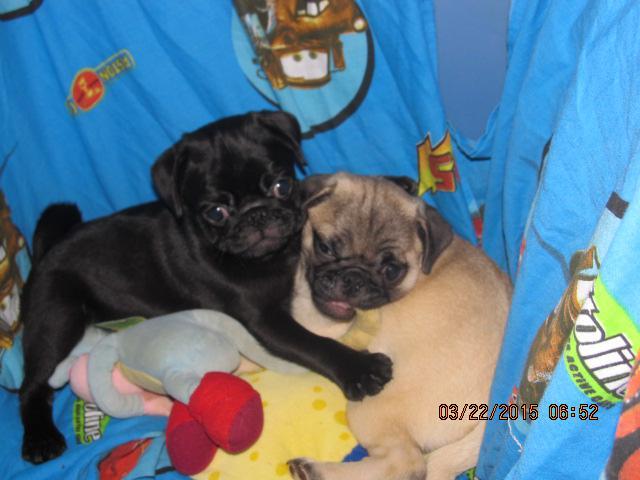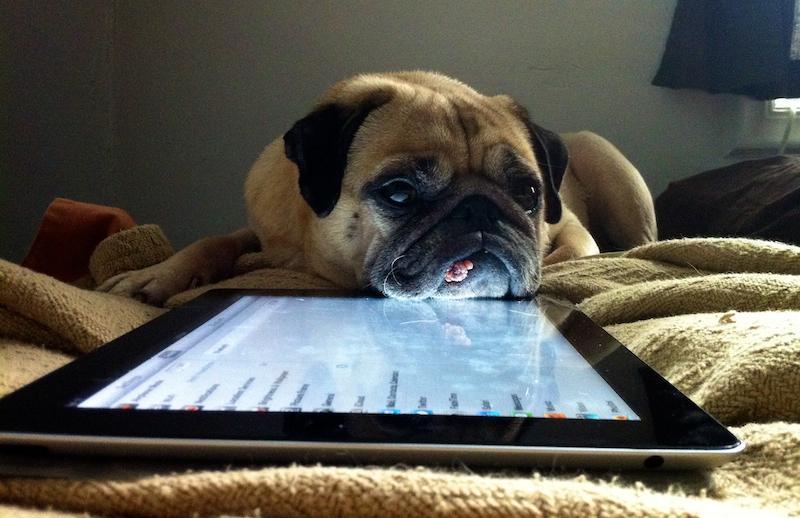The first image is the image on the left, the second image is the image on the right. Evaluate the accuracy of this statement regarding the images: "Each image contains a trio of pugs and includes at least two beige pugs with dark muzzles.". Is it true? Answer yes or no. No. The first image is the image on the left, the second image is the image on the right. Assess this claim about the two images: "There is at least one pug dog in the center of both images.". Correct or not? Answer yes or no. Yes. 